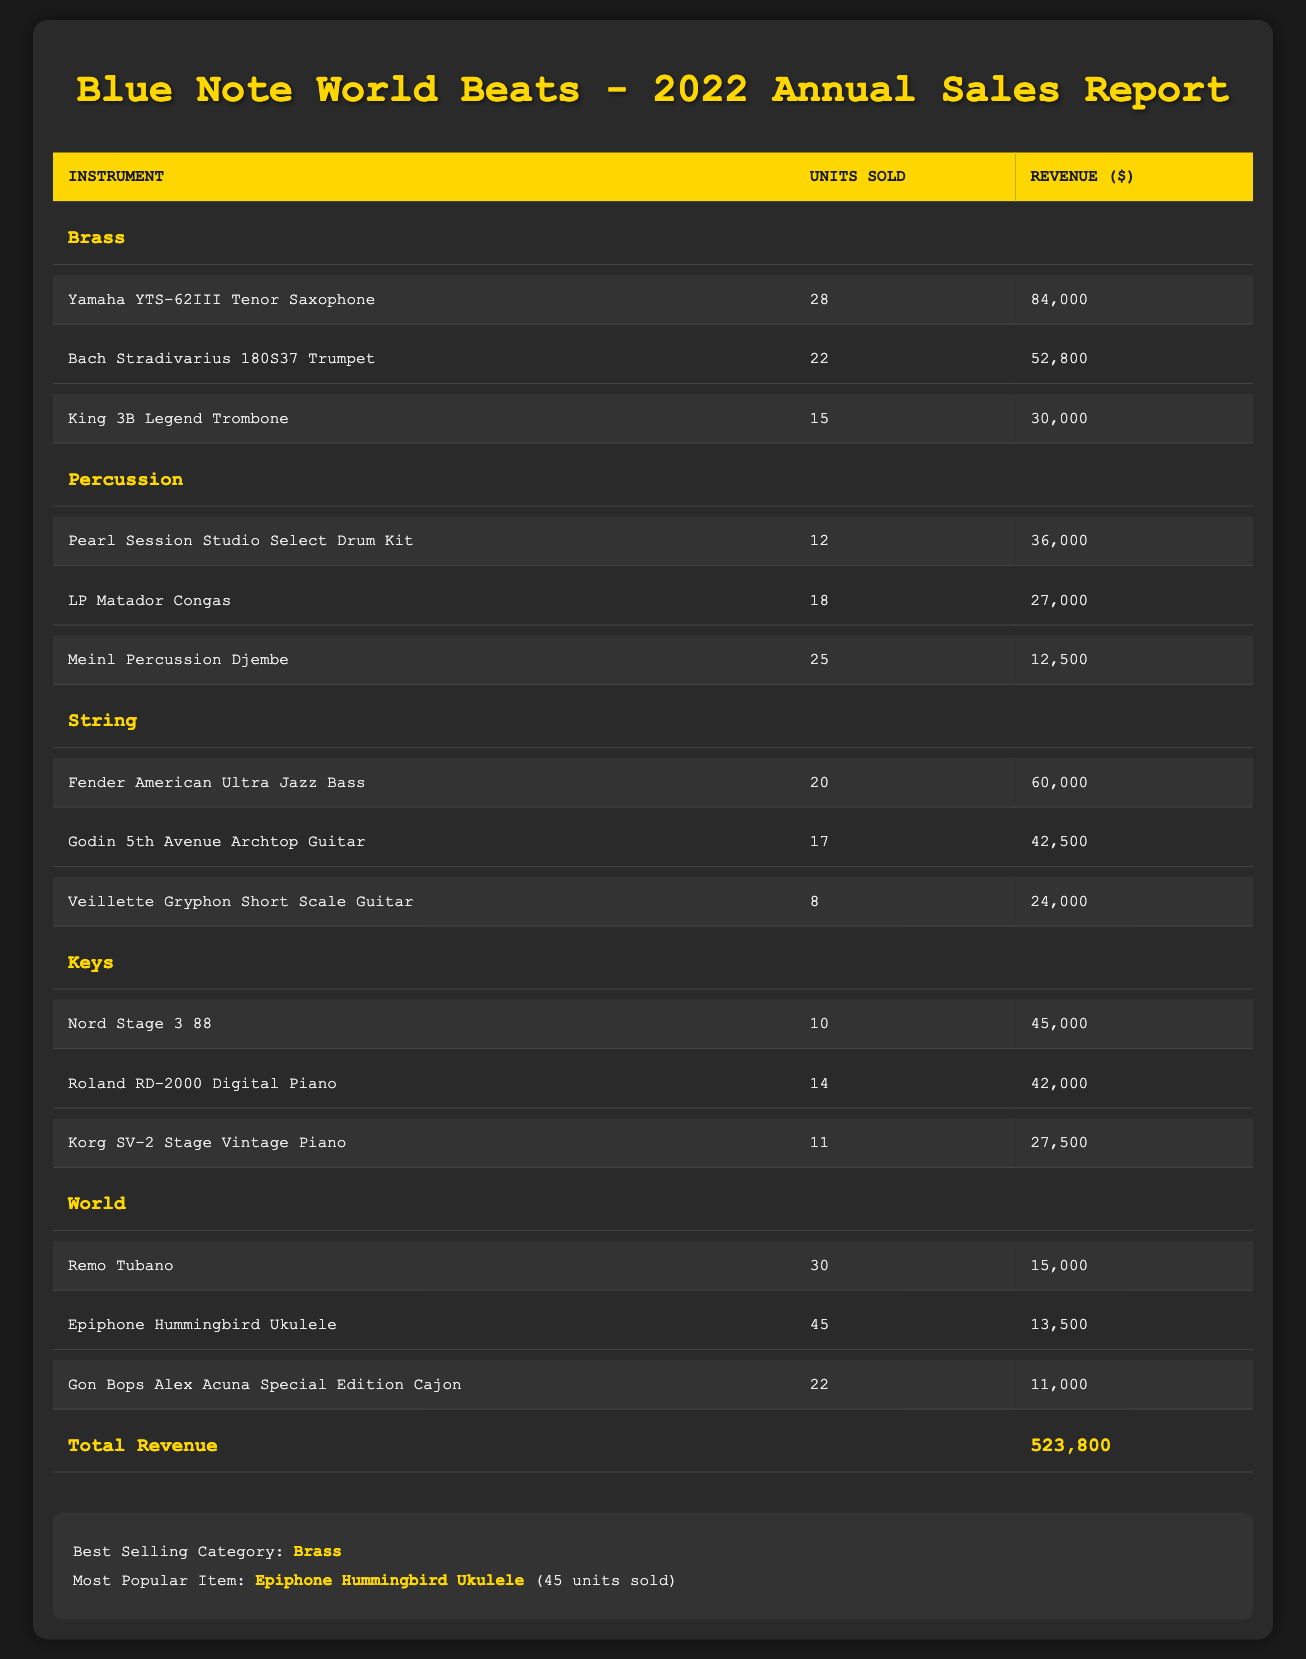What is the total revenue generated from instrument sales in 2022? The total revenue is explicitly stated in the last row of the table. It indicates that total revenue from all instrument sales for the year 2022 is 523,800.
Answer: 523,800 Which instrument category had the highest revenue? The best selling category is listed in the summary section of the table, which states that the Brass category had the highest revenue for the year 2022.
Answer: Brass How many units of the 'Yamaha YTS-62III Tenor Saxophone' were sold? The table lists the number of units sold for each instrument, and it shows that 28 units of the 'Yamaha YTS-62III Tenor Saxophone' were sold.
Answer: 28 What is the average revenue for instruments in the String category? The revenue figures for the String category instruments are 60,000, 42,500, and 24,000. To find the average, we calculate (60,000 + 42,500 + 24,000) / 3 = 42,500. Thus, the average revenue for the String category is 42,500.
Answer: 42,500 Did the 'Epiphone Hummingbird Ukulele' sell more units than the 'King 3B Legend Trombone'? The table indicates that the 'Epiphone Hummingbird Ukulele' sold 45 units, while the 'King 3B Legend Trombone' sold 15 units. Since 45 is greater than 15, the statement is true.
Answer: Yes Which two instrument categories had the highest and lowest total units sold, respectively? Summing the units sold for each category, we find that Brass: 65, Percussion: 55, String: 45, Keys: 35, and World: 97. Therefore, the highest is Brass with 65 units, and the lowest is Keys with 35 units sold.
Answer: Brass, Keys What is the total revenue contributed by percussion instruments? The table shows the revenue for each percussion instrument as follows: 36,000 (Pearl Session Studio Select Drum Kit), 27,000 (LP Matador Congas), and 12,500 (Meinl Percussion Djembe). The total revenue from percussion instruments is 36,000 + 27,000 + 12,500 = 75,500.
Answer: 75,500 Which instrument sold the highest number of units in the World category? Among the instruments listed in the World category, the 'Epiphone Hummingbird Ukulele' sold the highest number with 45 units, as indicated in the units sold column.
Answer: Epiphone Hummingbird Ukulele How many more units were sold in the Brass category compared to the World category? For the Brass category, the total units sold are 28 (Yamaha YTS-62III Tenor Saxophone) + 22 (Bach Stradivarius 180S37 Trumpet) + 15 (King 3B Legend Trombone) = 65 units. For the World category, the units sold are 30 (Remo Tubano) + 45 (Epiphone Hummingbird Ukulele) + 22 (Gon Bops Alex Acuna Special Edition Cajon) = 97 units. The difference is 65 - 97 = -32, indicating that the World category sold 32 more units than Brass.
Answer: World category sold 32 more units 